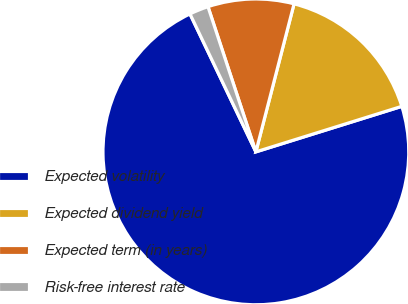Convert chart to OTSL. <chart><loc_0><loc_0><loc_500><loc_500><pie_chart><fcel>Expected volatility<fcel>Expected dividend yield<fcel>Expected term (in years)<fcel>Risk-free interest rate<nl><fcel>72.72%<fcel>16.17%<fcel>9.09%<fcel>2.02%<nl></chart> 